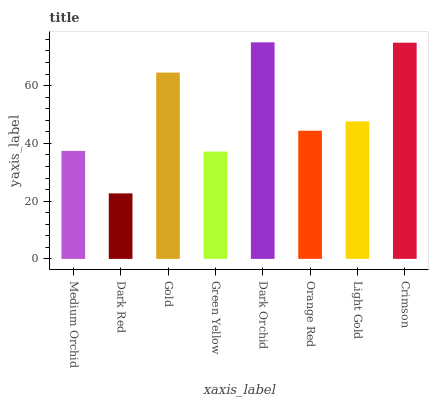Is Dark Red the minimum?
Answer yes or no. Yes. Is Dark Orchid the maximum?
Answer yes or no. Yes. Is Gold the minimum?
Answer yes or no. No. Is Gold the maximum?
Answer yes or no. No. Is Gold greater than Dark Red?
Answer yes or no. Yes. Is Dark Red less than Gold?
Answer yes or no. Yes. Is Dark Red greater than Gold?
Answer yes or no. No. Is Gold less than Dark Red?
Answer yes or no. No. Is Light Gold the high median?
Answer yes or no. Yes. Is Orange Red the low median?
Answer yes or no. Yes. Is Orange Red the high median?
Answer yes or no. No. Is Green Yellow the low median?
Answer yes or no. No. 